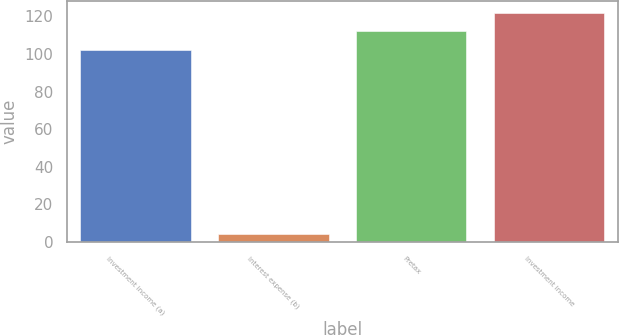Convert chart to OTSL. <chart><loc_0><loc_0><loc_500><loc_500><bar_chart><fcel>Investment income (a)<fcel>Interest expense (b)<fcel>Pretax<fcel>Investment income<nl><fcel>102<fcel>4.36<fcel>111.96<fcel>121.92<nl></chart> 